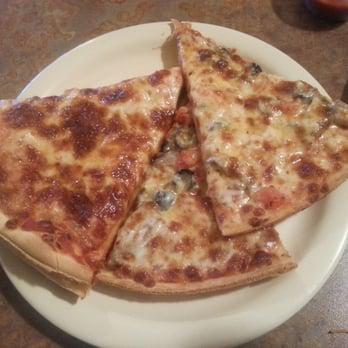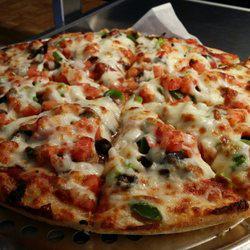The first image is the image on the left, the second image is the image on the right. Considering the images on both sides, is "One of the pizzas is placed next to some fresh uncut tomatoes." valid? Answer yes or no. No. The first image is the image on the left, the second image is the image on the right. For the images shown, is this caption "There is one whole pizza in the right image." true? Answer yes or no. Yes. 